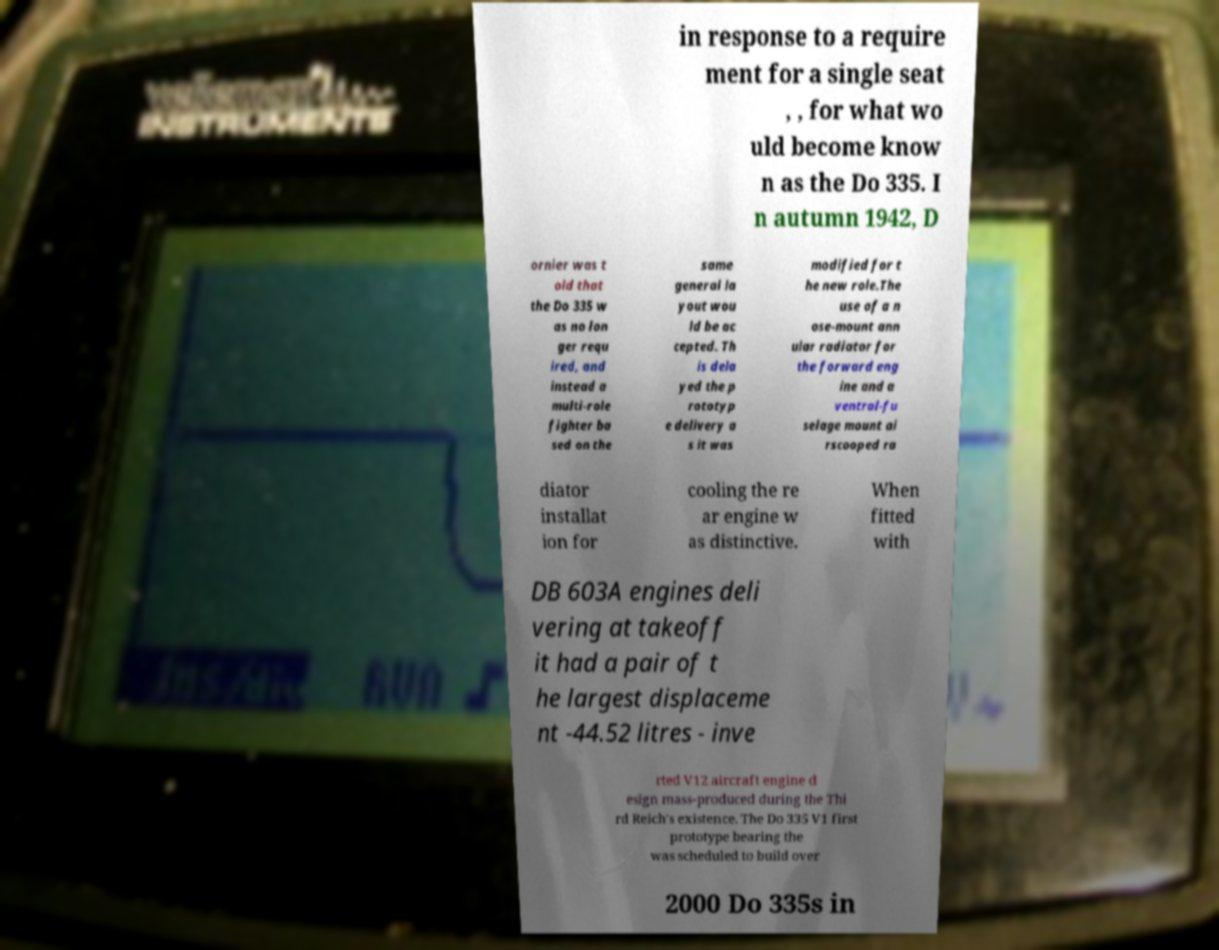Could you assist in decoding the text presented in this image and type it out clearly? in response to a require ment for a single seat , , for what wo uld become know n as the Do 335. I n autumn 1942, D ornier was t old that the Do 335 w as no lon ger requ ired, and instead a multi-role fighter ba sed on the same general la yout wou ld be ac cepted. Th is dela yed the p rototyp e delivery a s it was modified for t he new role.The use of a n ose-mount ann ular radiator for the forward eng ine and a ventral-fu selage mount ai rscooped ra diator installat ion for cooling the re ar engine w as distinctive. When fitted with DB 603A engines deli vering at takeoff it had a pair of t he largest displaceme nt -44.52 litres - inve rted V12 aircraft engine d esign mass-produced during the Thi rd Reich's existence. The Do 335 V1 first prototype bearing the was scheduled to build over 2000 Do 335s in 